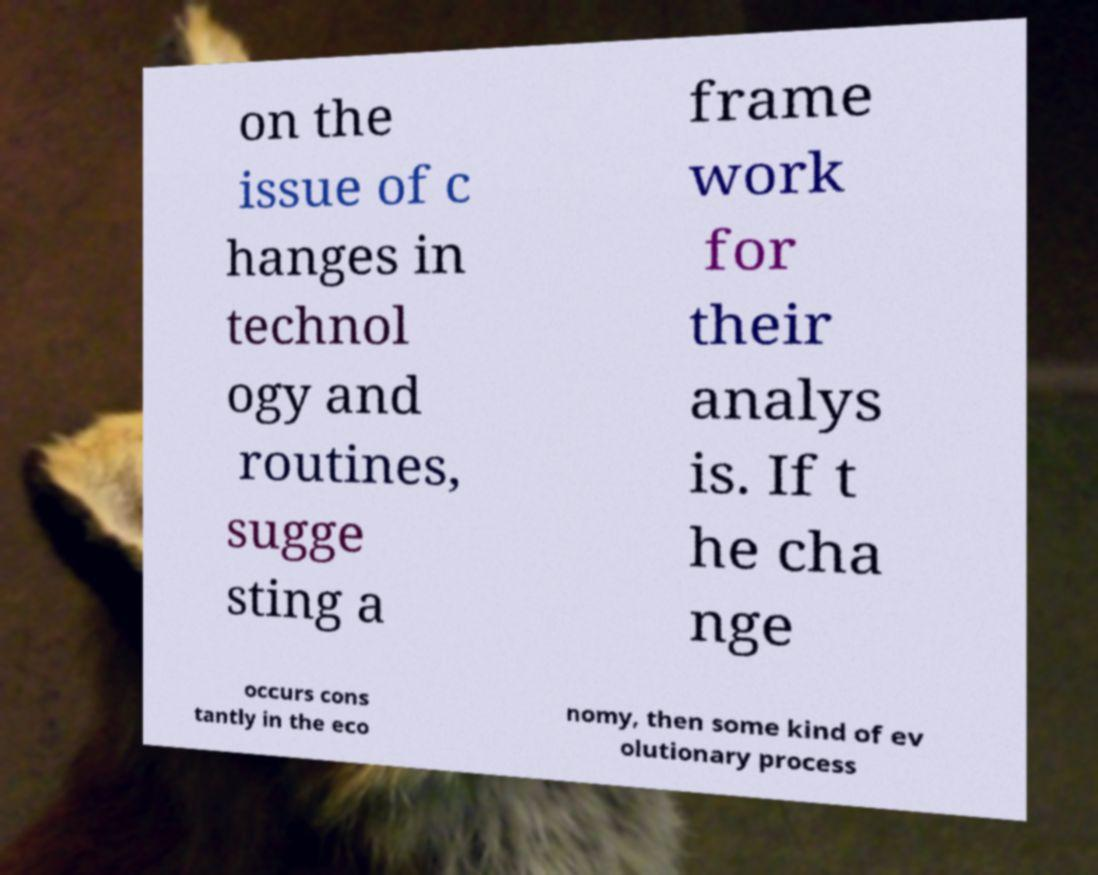There's text embedded in this image that I need extracted. Can you transcribe it verbatim? on the issue of c hanges in technol ogy and routines, sugge sting a frame work for their analys is. If t he cha nge occurs cons tantly in the eco nomy, then some kind of ev olutionary process 